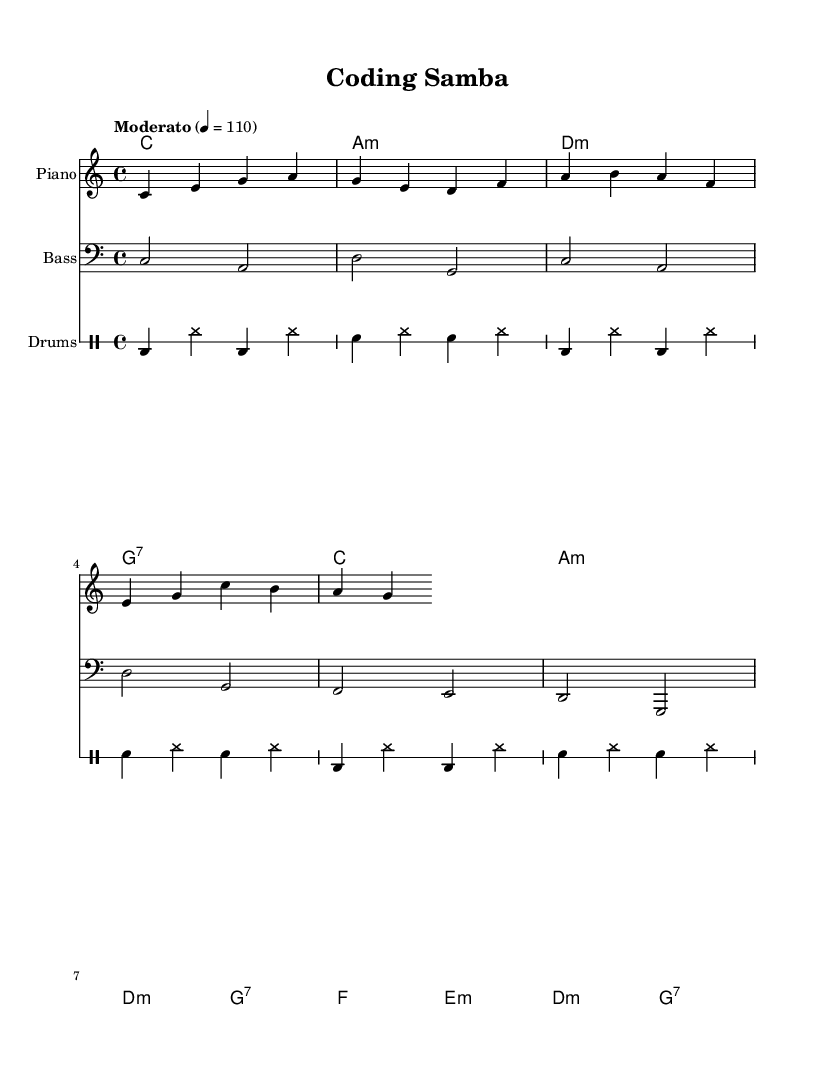What is the key signature of this music? The key signature is indicated at the beginning of the score, showing no sharps or flats, which identifies the key as C major.
Answer: C major What is the time signature of this piece? The time signature is shown at the beginning of the score as 4/4, which denotes four beats per measure.
Answer: 4/4 What is the tempo marking for this piece? The tempo marking "Moderato" is specified along with a metronome marking of 110 beats per minute, indicating a moderate speed.
Answer: Moderato How many measures are in the melody? The melody section consists of three distinct phrases, each aligning with a measure, leading to a total of six measures in the melody.
Answer: Six What instrument plays the melody? The score explicitly mentions the instrument name for the staff containing the melody, identifying it as "Piano".
Answer: Piano Which chord is played in the first measure? The first chord is indicated in the chord names as C major, which is shown at the start of the first measure.
Answer: C What is the lyrical theme of this piece? The lyrics reflect the theme of balancing work and life, with references to coding and meetings, suggesting a relatable scenario for those in the tech industry.
Answer: Work-life balance 